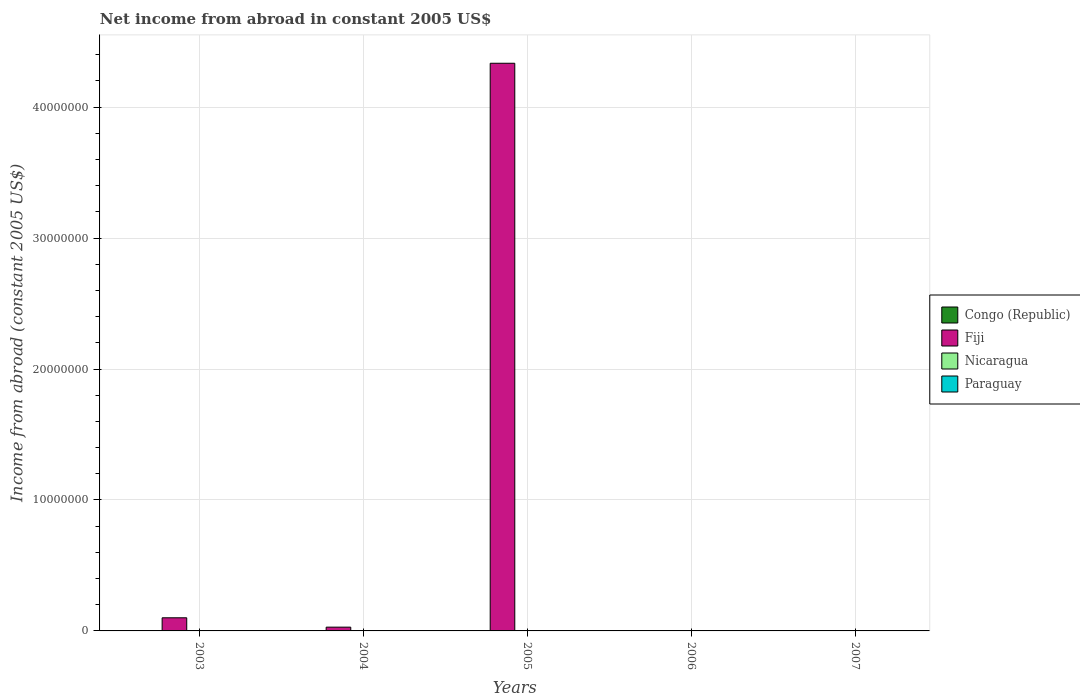How many different coloured bars are there?
Your answer should be very brief. 1. Are the number of bars on each tick of the X-axis equal?
Your answer should be compact. No. How many bars are there on the 1st tick from the left?
Give a very brief answer. 1. What is the label of the 5th group of bars from the left?
Provide a succinct answer. 2007. What is the net income from abroad in Congo (Republic) in 2003?
Make the answer very short. 0. Across all years, what is the maximum net income from abroad in Fiji?
Your answer should be compact. 4.33e+07. Across all years, what is the minimum net income from abroad in Nicaragua?
Your answer should be very brief. 0. In which year was the net income from abroad in Fiji maximum?
Offer a terse response. 2005. What is the total net income from abroad in Fiji in the graph?
Your response must be concise. 4.46e+07. What is the ratio of the net income from abroad in Fiji in 2003 to that in 2004?
Make the answer very short. 3.47. What is the difference between the highest and the second highest net income from abroad in Fiji?
Ensure brevity in your answer.  4.23e+07. What is the difference between the highest and the lowest net income from abroad in Fiji?
Make the answer very short. 4.33e+07. In how many years, is the net income from abroad in Nicaragua greater than the average net income from abroad in Nicaragua taken over all years?
Your answer should be compact. 0. Is it the case that in every year, the sum of the net income from abroad in Nicaragua and net income from abroad in Congo (Republic) is greater than the net income from abroad in Fiji?
Your response must be concise. No. How many bars are there?
Ensure brevity in your answer.  3. How many years are there in the graph?
Your answer should be very brief. 5. Does the graph contain grids?
Your answer should be very brief. Yes. Where does the legend appear in the graph?
Provide a succinct answer. Center right. How many legend labels are there?
Offer a very short reply. 4. How are the legend labels stacked?
Give a very brief answer. Vertical. What is the title of the graph?
Offer a very short reply. Net income from abroad in constant 2005 US$. Does "Macedonia" appear as one of the legend labels in the graph?
Offer a terse response. No. What is the label or title of the Y-axis?
Provide a short and direct response. Income from abroad (constant 2005 US$). What is the Income from abroad (constant 2005 US$) of Fiji in 2003?
Your answer should be very brief. 1.00e+06. What is the Income from abroad (constant 2005 US$) in Nicaragua in 2003?
Your answer should be very brief. 0. What is the Income from abroad (constant 2005 US$) in Fiji in 2004?
Make the answer very short. 2.89e+05. What is the Income from abroad (constant 2005 US$) in Nicaragua in 2004?
Your answer should be compact. 0. What is the Income from abroad (constant 2005 US$) in Paraguay in 2004?
Your answer should be compact. 0. What is the Income from abroad (constant 2005 US$) of Fiji in 2005?
Make the answer very short. 4.33e+07. What is the Income from abroad (constant 2005 US$) in Nicaragua in 2005?
Your response must be concise. 0. What is the Income from abroad (constant 2005 US$) in Paraguay in 2006?
Keep it short and to the point. 0. What is the Income from abroad (constant 2005 US$) of Congo (Republic) in 2007?
Ensure brevity in your answer.  0. Across all years, what is the maximum Income from abroad (constant 2005 US$) in Fiji?
Offer a terse response. 4.33e+07. What is the total Income from abroad (constant 2005 US$) in Congo (Republic) in the graph?
Provide a short and direct response. 0. What is the total Income from abroad (constant 2005 US$) of Fiji in the graph?
Provide a short and direct response. 4.46e+07. What is the total Income from abroad (constant 2005 US$) in Nicaragua in the graph?
Ensure brevity in your answer.  0. What is the total Income from abroad (constant 2005 US$) in Paraguay in the graph?
Make the answer very short. 0. What is the difference between the Income from abroad (constant 2005 US$) in Fiji in 2003 and that in 2004?
Your answer should be compact. 7.14e+05. What is the difference between the Income from abroad (constant 2005 US$) in Fiji in 2003 and that in 2005?
Your response must be concise. -4.23e+07. What is the difference between the Income from abroad (constant 2005 US$) of Fiji in 2004 and that in 2005?
Your answer should be compact. -4.31e+07. What is the average Income from abroad (constant 2005 US$) in Congo (Republic) per year?
Your answer should be very brief. 0. What is the average Income from abroad (constant 2005 US$) in Fiji per year?
Keep it short and to the point. 8.93e+06. What is the ratio of the Income from abroad (constant 2005 US$) of Fiji in 2003 to that in 2004?
Offer a terse response. 3.47. What is the ratio of the Income from abroad (constant 2005 US$) in Fiji in 2003 to that in 2005?
Offer a terse response. 0.02. What is the ratio of the Income from abroad (constant 2005 US$) of Fiji in 2004 to that in 2005?
Keep it short and to the point. 0.01. What is the difference between the highest and the second highest Income from abroad (constant 2005 US$) in Fiji?
Ensure brevity in your answer.  4.23e+07. What is the difference between the highest and the lowest Income from abroad (constant 2005 US$) in Fiji?
Ensure brevity in your answer.  4.33e+07. 